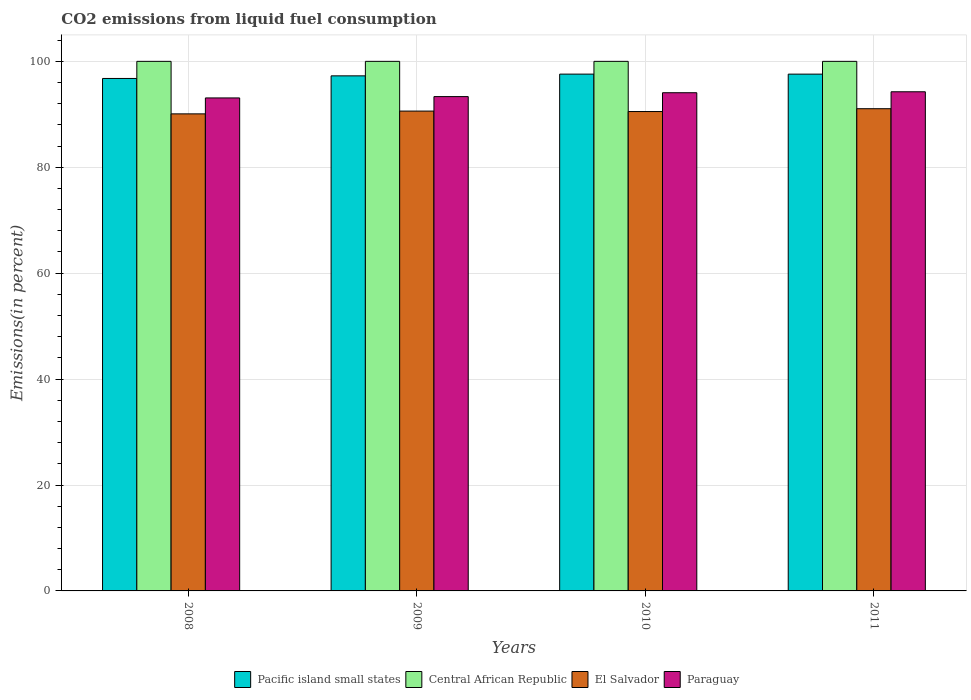Are the number of bars on each tick of the X-axis equal?
Your answer should be compact. Yes. How many bars are there on the 3rd tick from the left?
Offer a very short reply. 4. In how many cases, is the number of bars for a given year not equal to the number of legend labels?
Your response must be concise. 0. What is the total CO2 emitted in Central African Republic in 2011?
Your answer should be very brief. 100. Across all years, what is the maximum total CO2 emitted in Paraguay?
Your answer should be compact. 94.26. Across all years, what is the minimum total CO2 emitted in Central African Republic?
Provide a short and direct response. 100. In which year was the total CO2 emitted in Paraguay maximum?
Make the answer very short. 2011. In which year was the total CO2 emitted in Pacific island small states minimum?
Your answer should be compact. 2008. What is the total total CO2 emitted in El Salvador in the graph?
Your answer should be compact. 362.27. What is the difference between the total CO2 emitted in Pacific island small states in 2010 and that in 2011?
Give a very brief answer. 0. What is the difference between the total CO2 emitted in Central African Republic in 2008 and the total CO2 emitted in Paraguay in 2009?
Your answer should be compact. 6.66. What is the average total CO2 emitted in Pacific island small states per year?
Offer a very short reply. 97.3. In the year 2008, what is the difference between the total CO2 emitted in Paraguay and total CO2 emitted in El Salvador?
Your response must be concise. 3.01. What is the ratio of the total CO2 emitted in Pacific island small states in 2010 to that in 2011?
Offer a very short reply. 1. What is the difference between the highest and the second highest total CO2 emitted in El Salvador?
Give a very brief answer. 0.45. What is the difference between the highest and the lowest total CO2 emitted in Pacific island small states?
Make the answer very short. 0.82. In how many years, is the total CO2 emitted in Paraguay greater than the average total CO2 emitted in Paraguay taken over all years?
Provide a short and direct response. 2. Is the sum of the total CO2 emitted in Paraguay in 2008 and 2010 greater than the maximum total CO2 emitted in Central African Republic across all years?
Your answer should be compact. Yes. What does the 1st bar from the left in 2008 represents?
Make the answer very short. Pacific island small states. What does the 2nd bar from the right in 2009 represents?
Provide a succinct answer. El Salvador. How many years are there in the graph?
Make the answer very short. 4. What is the difference between two consecutive major ticks on the Y-axis?
Make the answer very short. 20. Are the values on the major ticks of Y-axis written in scientific E-notation?
Ensure brevity in your answer.  No. How many legend labels are there?
Your answer should be compact. 4. What is the title of the graph?
Your answer should be compact. CO2 emissions from liquid fuel consumption. Does "Gabon" appear as one of the legend labels in the graph?
Provide a succinct answer. No. What is the label or title of the X-axis?
Your answer should be compact. Years. What is the label or title of the Y-axis?
Ensure brevity in your answer.  Emissions(in percent). What is the Emissions(in percent) in Pacific island small states in 2008?
Give a very brief answer. 96.77. What is the Emissions(in percent) of Central African Republic in 2008?
Your response must be concise. 100. What is the Emissions(in percent) of El Salvador in 2008?
Your answer should be compact. 90.08. What is the Emissions(in percent) in Paraguay in 2008?
Offer a terse response. 93.09. What is the Emissions(in percent) of Pacific island small states in 2009?
Make the answer very short. 97.26. What is the Emissions(in percent) of El Salvador in 2009?
Offer a terse response. 90.61. What is the Emissions(in percent) of Paraguay in 2009?
Offer a terse response. 93.34. What is the Emissions(in percent) of Pacific island small states in 2010?
Offer a very short reply. 97.59. What is the Emissions(in percent) in Central African Republic in 2010?
Provide a short and direct response. 100. What is the Emissions(in percent) of El Salvador in 2010?
Provide a succinct answer. 90.52. What is the Emissions(in percent) in Paraguay in 2010?
Provide a short and direct response. 94.08. What is the Emissions(in percent) of Pacific island small states in 2011?
Offer a very short reply. 97.59. What is the Emissions(in percent) of El Salvador in 2011?
Keep it short and to the point. 91.06. What is the Emissions(in percent) in Paraguay in 2011?
Give a very brief answer. 94.26. Across all years, what is the maximum Emissions(in percent) in Pacific island small states?
Make the answer very short. 97.59. Across all years, what is the maximum Emissions(in percent) of El Salvador?
Make the answer very short. 91.06. Across all years, what is the maximum Emissions(in percent) in Paraguay?
Offer a very short reply. 94.26. Across all years, what is the minimum Emissions(in percent) of Pacific island small states?
Provide a succinct answer. 96.77. Across all years, what is the minimum Emissions(in percent) of Central African Republic?
Your answer should be compact. 100. Across all years, what is the minimum Emissions(in percent) in El Salvador?
Your response must be concise. 90.08. Across all years, what is the minimum Emissions(in percent) in Paraguay?
Your answer should be compact. 93.09. What is the total Emissions(in percent) of Pacific island small states in the graph?
Your answer should be very brief. 389.21. What is the total Emissions(in percent) in Central African Republic in the graph?
Make the answer very short. 400. What is the total Emissions(in percent) in El Salvador in the graph?
Your answer should be very brief. 362.27. What is the total Emissions(in percent) in Paraguay in the graph?
Your answer should be compact. 374.77. What is the difference between the Emissions(in percent) of Pacific island small states in 2008 and that in 2009?
Make the answer very short. -0.49. What is the difference between the Emissions(in percent) of Central African Republic in 2008 and that in 2009?
Your answer should be compact. 0. What is the difference between the Emissions(in percent) of El Salvador in 2008 and that in 2009?
Ensure brevity in your answer.  -0.53. What is the difference between the Emissions(in percent) in Paraguay in 2008 and that in 2009?
Your answer should be compact. -0.25. What is the difference between the Emissions(in percent) in Pacific island small states in 2008 and that in 2010?
Your answer should be compact. -0.82. What is the difference between the Emissions(in percent) of Central African Republic in 2008 and that in 2010?
Ensure brevity in your answer.  0. What is the difference between the Emissions(in percent) of El Salvador in 2008 and that in 2010?
Provide a short and direct response. -0.44. What is the difference between the Emissions(in percent) of Paraguay in 2008 and that in 2010?
Your answer should be compact. -0.98. What is the difference between the Emissions(in percent) of Pacific island small states in 2008 and that in 2011?
Offer a very short reply. -0.82. What is the difference between the Emissions(in percent) in El Salvador in 2008 and that in 2011?
Ensure brevity in your answer.  -0.97. What is the difference between the Emissions(in percent) in Paraguay in 2008 and that in 2011?
Offer a very short reply. -1.16. What is the difference between the Emissions(in percent) in Pacific island small states in 2009 and that in 2010?
Ensure brevity in your answer.  -0.33. What is the difference between the Emissions(in percent) of El Salvador in 2009 and that in 2010?
Your response must be concise. 0.09. What is the difference between the Emissions(in percent) of Paraguay in 2009 and that in 2010?
Keep it short and to the point. -0.73. What is the difference between the Emissions(in percent) in Pacific island small states in 2009 and that in 2011?
Your response must be concise. -0.32. What is the difference between the Emissions(in percent) in El Salvador in 2009 and that in 2011?
Your answer should be very brief. -0.45. What is the difference between the Emissions(in percent) of Paraguay in 2009 and that in 2011?
Offer a very short reply. -0.91. What is the difference between the Emissions(in percent) of Pacific island small states in 2010 and that in 2011?
Provide a short and direct response. 0. What is the difference between the Emissions(in percent) of Central African Republic in 2010 and that in 2011?
Provide a short and direct response. 0. What is the difference between the Emissions(in percent) of El Salvador in 2010 and that in 2011?
Your answer should be compact. -0.54. What is the difference between the Emissions(in percent) of Paraguay in 2010 and that in 2011?
Make the answer very short. -0.18. What is the difference between the Emissions(in percent) of Pacific island small states in 2008 and the Emissions(in percent) of Central African Republic in 2009?
Your answer should be compact. -3.23. What is the difference between the Emissions(in percent) in Pacific island small states in 2008 and the Emissions(in percent) in El Salvador in 2009?
Ensure brevity in your answer.  6.16. What is the difference between the Emissions(in percent) of Pacific island small states in 2008 and the Emissions(in percent) of Paraguay in 2009?
Provide a short and direct response. 3.42. What is the difference between the Emissions(in percent) in Central African Republic in 2008 and the Emissions(in percent) in El Salvador in 2009?
Make the answer very short. 9.39. What is the difference between the Emissions(in percent) of Central African Republic in 2008 and the Emissions(in percent) of Paraguay in 2009?
Make the answer very short. 6.66. What is the difference between the Emissions(in percent) of El Salvador in 2008 and the Emissions(in percent) of Paraguay in 2009?
Offer a very short reply. -3.26. What is the difference between the Emissions(in percent) of Pacific island small states in 2008 and the Emissions(in percent) of Central African Republic in 2010?
Offer a terse response. -3.23. What is the difference between the Emissions(in percent) in Pacific island small states in 2008 and the Emissions(in percent) in El Salvador in 2010?
Offer a very short reply. 6.25. What is the difference between the Emissions(in percent) in Pacific island small states in 2008 and the Emissions(in percent) in Paraguay in 2010?
Keep it short and to the point. 2.69. What is the difference between the Emissions(in percent) of Central African Republic in 2008 and the Emissions(in percent) of El Salvador in 2010?
Your response must be concise. 9.48. What is the difference between the Emissions(in percent) of Central African Republic in 2008 and the Emissions(in percent) of Paraguay in 2010?
Make the answer very short. 5.92. What is the difference between the Emissions(in percent) of El Salvador in 2008 and the Emissions(in percent) of Paraguay in 2010?
Provide a short and direct response. -3.99. What is the difference between the Emissions(in percent) of Pacific island small states in 2008 and the Emissions(in percent) of Central African Republic in 2011?
Your answer should be very brief. -3.23. What is the difference between the Emissions(in percent) of Pacific island small states in 2008 and the Emissions(in percent) of El Salvador in 2011?
Provide a short and direct response. 5.71. What is the difference between the Emissions(in percent) of Pacific island small states in 2008 and the Emissions(in percent) of Paraguay in 2011?
Provide a succinct answer. 2.51. What is the difference between the Emissions(in percent) in Central African Republic in 2008 and the Emissions(in percent) in El Salvador in 2011?
Your answer should be very brief. 8.94. What is the difference between the Emissions(in percent) of Central African Republic in 2008 and the Emissions(in percent) of Paraguay in 2011?
Your answer should be compact. 5.74. What is the difference between the Emissions(in percent) in El Salvador in 2008 and the Emissions(in percent) in Paraguay in 2011?
Keep it short and to the point. -4.17. What is the difference between the Emissions(in percent) of Pacific island small states in 2009 and the Emissions(in percent) of Central African Republic in 2010?
Ensure brevity in your answer.  -2.74. What is the difference between the Emissions(in percent) in Pacific island small states in 2009 and the Emissions(in percent) in El Salvador in 2010?
Your response must be concise. 6.74. What is the difference between the Emissions(in percent) of Pacific island small states in 2009 and the Emissions(in percent) of Paraguay in 2010?
Offer a very short reply. 3.19. What is the difference between the Emissions(in percent) in Central African Republic in 2009 and the Emissions(in percent) in El Salvador in 2010?
Offer a terse response. 9.48. What is the difference between the Emissions(in percent) of Central African Republic in 2009 and the Emissions(in percent) of Paraguay in 2010?
Offer a terse response. 5.92. What is the difference between the Emissions(in percent) in El Salvador in 2009 and the Emissions(in percent) in Paraguay in 2010?
Make the answer very short. -3.47. What is the difference between the Emissions(in percent) of Pacific island small states in 2009 and the Emissions(in percent) of Central African Republic in 2011?
Provide a succinct answer. -2.74. What is the difference between the Emissions(in percent) in Pacific island small states in 2009 and the Emissions(in percent) in El Salvador in 2011?
Give a very brief answer. 6.2. What is the difference between the Emissions(in percent) of Pacific island small states in 2009 and the Emissions(in percent) of Paraguay in 2011?
Give a very brief answer. 3.01. What is the difference between the Emissions(in percent) in Central African Republic in 2009 and the Emissions(in percent) in El Salvador in 2011?
Give a very brief answer. 8.94. What is the difference between the Emissions(in percent) in Central African Republic in 2009 and the Emissions(in percent) in Paraguay in 2011?
Give a very brief answer. 5.74. What is the difference between the Emissions(in percent) of El Salvador in 2009 and the Emissions(in percent) of Paraguay in 2011?
Offer a very short reply. -3.65. What is the difference between the Emissions(in percent) of Pacific island small states in 2010 and the Emissions(in percent) of Central African Republic in 2011?
Keep it short and to the point. -2.41. What is the difference between the Emissions(in percent) in Pacific island small states in 2010 and the Emissions(in percent) in El Salvador in 2011?
Ensure brevity in your answer.  6.53. What is the difference between the Emissions(in percent) in Pacific island small states in 2010 and the Emissions(in percent) in Paraguay in 2011?
Your response must be concise. 3.33. What is the difference between the Emissions(in percent) in Central African Republic in 2010 and the Emissions(in percent) in El Salvador in 2011?
Your answer should be very brief. 8.94. What is the difference between the Emissions(in percent) of Central African Republic in 2010 and the Emissions(in percent) of Paraguay in 2011?
Make the answer very short. 5.74. What is the difference between the Emissions(in percent) in El Salvador in 2010 and the Emissions(in percent) in Paraguay in 2011?
Ensure brevity in your answer.  -3.73. What is the average Emissions(in percent) of Pacific island small states per year?
Your response must be concise. 97.3. What is the average Emissions(in percent) of El Salvador per year?
Your response must be concise. 90.57. What is the average Emissions(in percent) of Paraguay per year?
Give a very brief answer. 93.69. In the year 2008, what is the difference between the Emissions(in percent) in Pacific island small states and Emissions(in percent) in Central African Republic?
Provide a succinct answer. -3.23. In the year 2008, what is the difference between the Emissions(in percent) of Pacific island small states and Emissions(in percent) of El Salvador?
Offer a terse response. 6.68. In the year 2008, what is the difference between the Emissions(in percent) in Pacific island small states and Emissions(in percent) in Paraguay?
Make the answer very short. 3.68. In the year 2008, what is the difference between the Emissions(in percent) of Central African Republic and Emissions(in percent) of El Salvador?
Offer a terse response. 9.92. In the year 2008, what is the difference between the Emissions(in percent) in Central African Republic and Emissions(in percent) in Paraguay?
Your answer should be compact. 6.91. In the year 2008, what is the difference between the Emissions(in percent) in El Salvador and Emissions(in percent) in Paraguay?
Offer a terse response. -3.01. In the year 2009, what is the difference between the Emissions(in percent) of Pacific island small states and Emissions(in percent) of Central African Republic?
Make the answer very short. -2.74. In the year 2009, what is the difference between the Emissions(in percent) of Pacific island small states and Emissions(in percent) of El Salvador?
Make the answer very short. 6.65. In the year 2009, what is the difference between the Emissions(in percent) of Pacific island small states and Emissions(in percent) of Paraguay?
Your answer should be very brief. 3.92. In the year 2009, what is the difference between the Emissions(in percent) of Central African Republic and Emissions(in percent) of El Salvador?
Give a very brief answer. 9.39. In the year 2009, what is the difference between the Emissions(in percent) of Central African Republic and Emissions(in percent) of Paraguay?
Offer a terse response. 6.66. In the year 2009, what is the difference between the Emissions(in percent) of El Salvador and Emissions(in percent) of Paraguay?
Offer a very short reply. -2.74. In the year 2010, what is the difference between the Emissions(in percent) of Pacific island small states and Emissions(in percent) of Central African Republic?
Provide a short and direct response. -2.41. In the year 2010, what is the difference between the Emissions(in percent) in Pacific island small states and Emissions(in percent) in El Salvador?
Offer a terse response. 7.07. In the year 2010, what is the difference between the Emissions(in percent) of Pacific island small states and Emissions(in percent) of Paraguay?
Give a very brief answer. 3.52. In the year 2010, what is the difference between the Emissions(in percent) of Central African Republic and Emissions(in percent) of El Salvador?
Give a very brief answer. 9.48. In the year 2010, what is the difference between the Emissions(in percent) of Central African Republic and Emissions(in percent) of Paraguay?
Your answer should be very brief. 5.92. In the year 2010, what is the difference between the Emissions(in percent) of El Salvador and Emissions(in percent) of Paraguay?
Your answer should be compact. -3.55. In the year 2011, what is the difference between the Emissions(in percent) of Pacific island small states and Emissions(in percent) of Central African Republic?
Give a very brief answer. -2.41. In the year 2011, what is the difference between the Emissions(in percent) in Pacific island small states and Emissions(in percent) in El Salvador?
Offer a terse response. 6.53. In the year 2011, what is the difference between the Emissions(in percent) of Pacific island small states and Emissions(in percent) of Paraguay?
Your answer should be very brief. 3.33. In the year 2011, what is the difference between the Emissions(in percent) of Central African Republic and Emissions(in percent) of El Salvador?
Provide a succinct answer. 8.94. In the year 2011, what is the difference between the Emissions(in percent) in Central African Republic and Emissions(in percent) in Paraguay?
Offer a terse response. 5.74. In the year 2011, what is the difference between the Emissions(in percent) of El Salvador and Emissions(in percent) of Paraguay?
Your response must be concise. -3.2. What is the ratio of the Emissions(in percent) in Central African Republic in 2008 to that in 2009?
Your answer should be very brief. 1. What is the ratio of the Emissions(in percent) of Central African Republic in 2008 to that in 2010?
Make the answer very short. 1. What is the ratio of the Emissions(in percent) in El Salvador in 2008 to that in 2010?
Keep it short and to the point. 1. What is the ratio of the Emissions(in percent) in Paraguay in 2008 to that in 2010?
Keep it short and to the point. 0.99. What is the ratio of the Emissions(in percent) in Pacific island small states in 2008 to that in 2011?
Keep it short and to the point. 0.99. What is the ratio of the Emissions(in percent) in El Salvador in 2008 to that in 2011?
Give a very brief answer. 0.99. What is the ratio of the Emissions(in percent) of Paraguay in 2008 to that in 2011?
Give a very brief answer. 0.99. What is the ratio of the Emissions(in percent) of Central African Republic in 2009 to that in 2010?
Provide a succinct answer. 1. What is the ratio of the Emissions(in percent) in Pacific island small states in 2009 to that in 2011?
Give a very brief answer. 1. What is the ratio of the Emissions(in percent) of Central African Republic in 2009 to that in 2011?
Ensure brevity in your answer.  1. What is the ratio of the Emissions(in percent) of Paraguay in 2009 to that in 2011?
Give a very brief answer. 0.99. What is the ratio of the Emissions(in percent) of Central African Republic in 2010 to that in 2011?
Your answer should be compact. 1. What is the difference between the highest and the second highest Emissions(in percent) in Pacific island small states?
Ensure brevity in your answer.  0. What is the difference between the highest and the second highest Emissions(in percent) of El Salvador?
Your answer should be very brief. 0.45. What is the difference between the highest and the second highest Emissions(in percent) of Paraguay?
Offer a very short reply. 0.18. What is the difference between the highest and the lowest Emissions(in percent) in Pacific island small states?
Your answer should be very brief. 0.82. What is the difference between the highest and the lowest Emissions(in percent) in El Salvador?
Your answer should be compact. 0.97. What is the difference between the highest and the lowest Emissions(in percent) in Paraguay?
Offer a very short reply. 1.16. 